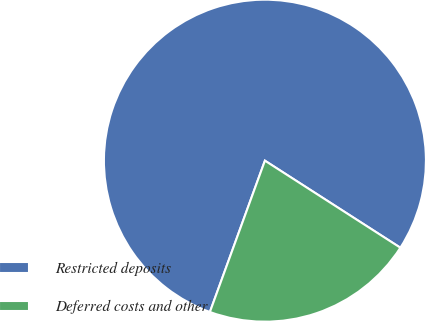Convert chart. <chart><loc_0><loc_0><loc_500><loc_500><pie_chart><fcel>Restricted deposits<fcel>Deferred costs and other<nl><fcel>78.54%<fcel>21.46%<nl></chart> 